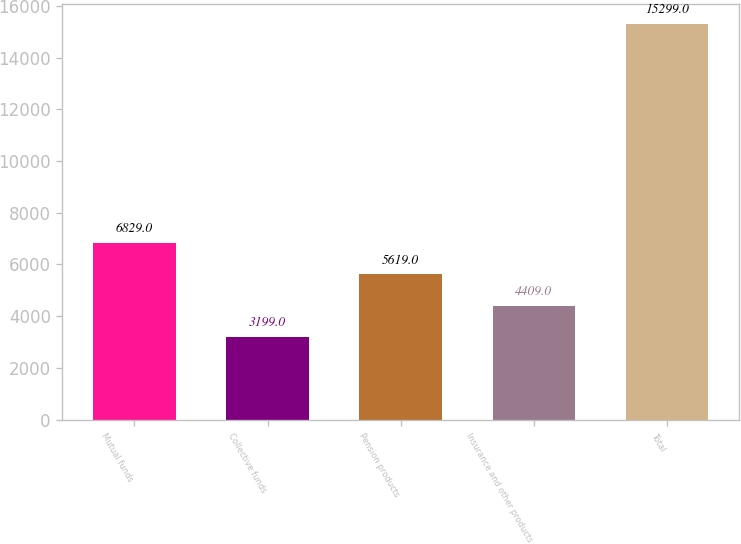Convert chart. <chart><loc_0><loc_0><loc_500><loc_500><bar_chart><fcel>Mutual funds<fcel>Collective funds<fcel>Pension products<fcel>Insurance and other products<fcel>Total<nl><fcel>6829<fcel>3199<fcel>5619<fcel>4409<fcel>15299<nl></chart> 